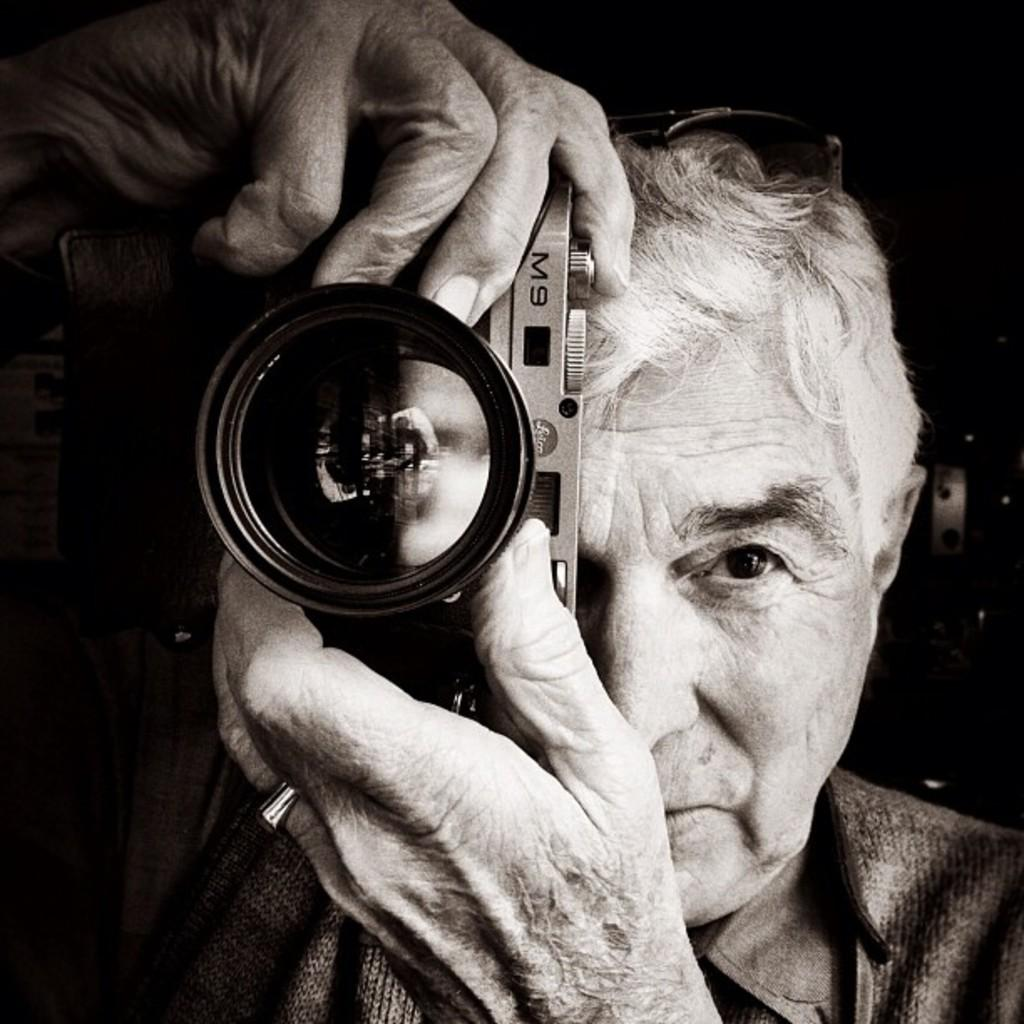Who is the main subject in the picture? There is an old man in the picture. What is the old man wearing? The old man is wearing a sweatshirt. Are there any accessories visible on the old man? Yes, the old man is wearing a silver ring on his finger. What is the old man holding in his hand? The old man is holding a camera in his hand. What is the old man doing in the picture? The old man is posing for the photograph. Can you tell me how many owls are sitting on the boat in the image? There are no owls or boats present in the image; it features an old man posing for a photograph. 